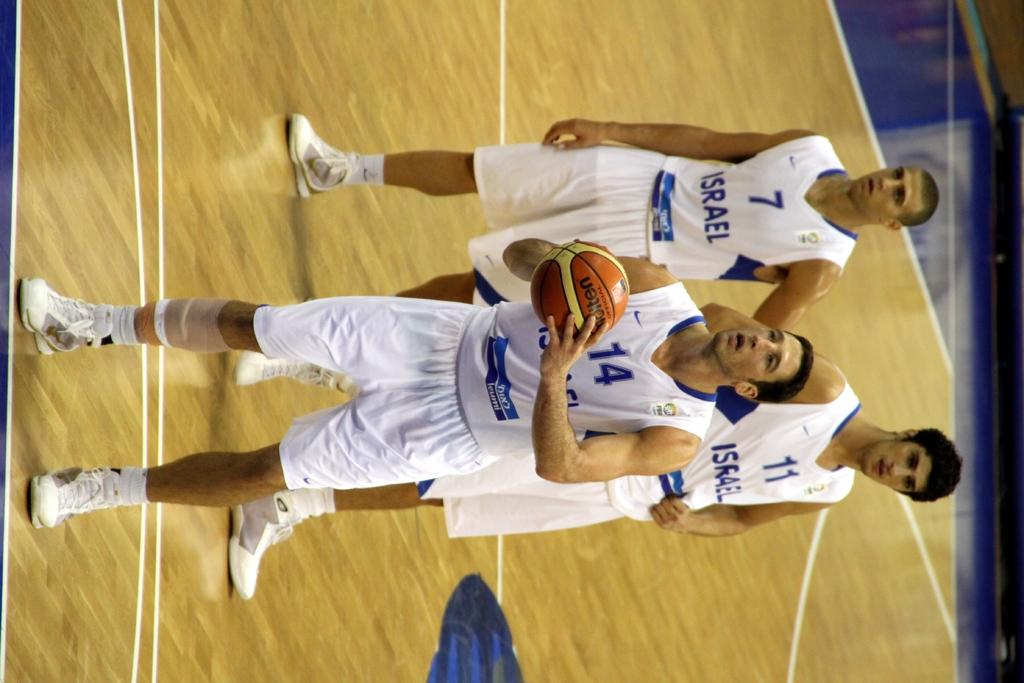What is the number of the player with the ball?
Your answer should be compact. 14. They play what game?
Your response must be concise. Answering does not require reading text in the image. 